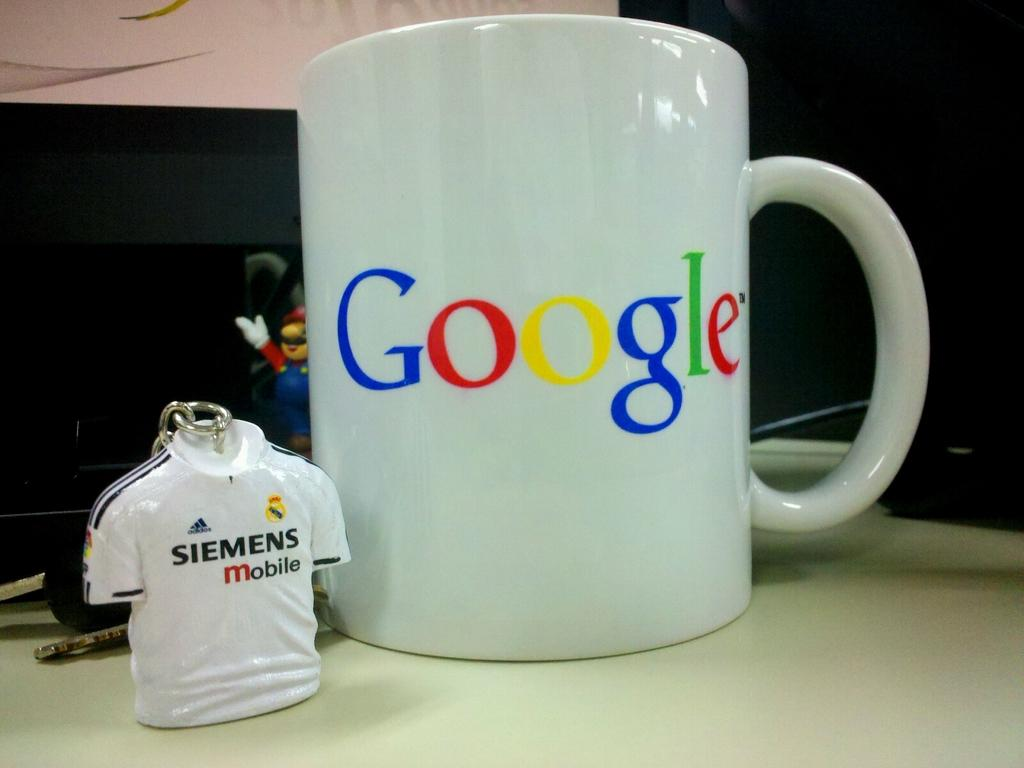<image>
Summarize the visual content of the image. white google mug next to a siemens mobile keychain 